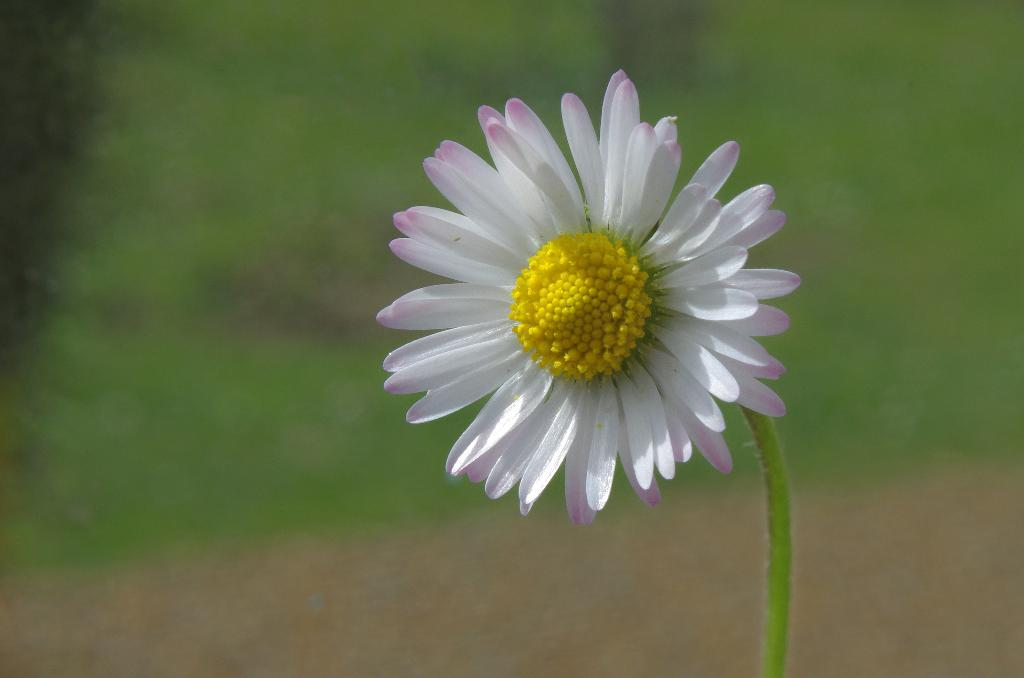Where was the image taken? The image was taken outdoors. Can you describe the background of the image? The background of the image is blurred and green in color. What is the main subject of the image? There is a flower in the image. What is the color of the flower? The flower is light pink in color. What type of form is the airplane flying in the image? There is no airplane present in the image, so it is not possible to answer that question. 